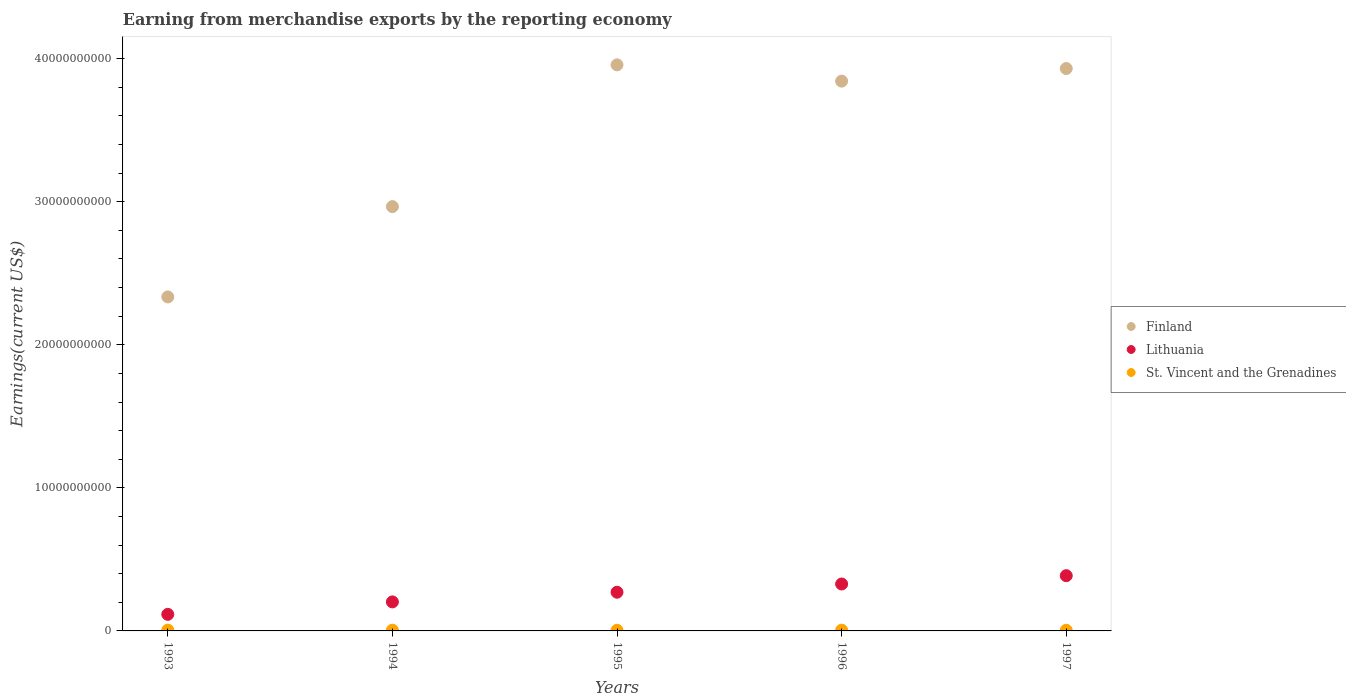How many different coloured dotlines are there?
Keep it short and to the point. 3. What is the amount earned from merchandise exports in Lithuania in 1995?
Ensure brevity in your answer.  2.71e+09. Across all years, what is the maximum amount earned from merchandise exports in St. Vincent and the Grenadines?
Keep it short and to the point. 5.79e+07. Across all years, what is the minimum amount earned from merchandise exports in St. Vincent and the Grenadines?
Your answer should be very brief. 4.45e+07. In which year was the amount earned from merchandise exports in Finland minimum?
Offer a terse response. 1993. What is the total amount earned from merchandise exports in Finland in the graph?
Provide a succinct answer. 1.70e+11. What is the difference between the amount earned from merchandise exports in Finland in 1995 and that in 1996?
Offer a terse response. 1.14e+09. What is the difference between the amount earned from merchandise exports in Lithuania in 1993 and the amount earned from merchandise exports in Finland in 1994?
Make the answer very short. -2.85e+1. What is the average amount earned from merchandise exports in Lithuania per year?
Your response must be concise. 2.61e+09. In the year 1995, what is the difference between the amount earned from merchandise exports in Finland and amount earned from merchandise exports in St. Vincent and the Grenadines?
Keep it short and to the point. 3.95e+1. What is the ratio of the amount earned from merchandise exports in St. Vincent and the Grenadines in 1993 to that in 1995?
Your answer should be compact. 1.3. What is the difference between the highest and the second highest amount earned from merchandise exports in Lithuania?
Provide a succinct answer. 5.81e+08. What is the difference between the highest and the lowest amount earned from merchandise exports in St. Vincent and the Grenadines?
Your answer should be compact. 1.33e+07. In how many years, is the amount earned from merchandise exports in Lithuania greater than the average amount earned from merchandise exports in Lithuania taken over all years?
Ensure brevity in your answer.  3. Is the sum of the amount earned from merchandise exports in Lithuania in 1995 and 1997 greater than the maximum amount earned from merchandise exports in St. Vincent and the Grenadines across all years?
Give a very brief answer. Yes. Is it the case that in every year, the sum of the amount earned from merchandise exports in St. Vincent and the Grenadines and amount earned from merchandise exports in Lithuania  is greater than the amount earned from merchandise exports in Finland?
Your response must be concise. No. Is the amount earned from merchandise exports in Finland strictly greater than the amount earned from merchandise exports in St. Vincent and the Grenadines over the years?
Ensure brevity in your answer.  Yes. Is the amount earned from merchandise exports in Finland strictly less than the amount earned from merchandise exports in St. Vincent and the Grenadines over the years?
Keep it short and to the point. No. How many dotlines are there?
Your answer should be compact. 3. How many years are there in the graph?
Your answer should be compact. 5. What is the difference between two consecutive major ticks on the Y-axis?
Give a very brief answer. 1.00e+1. Does the graph contain any zero values?
Your answer should be compact. No. Does the graph contain grids?
Provide a succinct answer. No. Where does the legend appear in the graph?
Make the answer very short. Center right. How many legend labels are there?
Your answer should be very brief. 3. What is the title of the graph?
Your answer should be compact. Earning from merchandise exports by the reporting economy. Does "Euro area" appear as one of the legend labels in the graph?
Give a very brief answer. No. What is the label or title of the X-axis?
Offer a very short reply. Years. What is the label or title of the Y-axis?
Offer a terse response. Earnings(current US$). What is the Earnings(current US$) of Finland in 1993?
Your response must be concise. 2.33e+1. What is the Earnings(current US$) in Lithuania in 1993?
Your answer should be compact. 1.16e+09. What is the Earnings(current US$) in St. Vincent and the Grenadines in 1993?
Provide a succinct answer. 5.79e+07. What is the Earnings(current US$) of Finland in 1994?
Your response must be concise. 2.97e+1. What is the Earnings(current US$) of Lithuania in 1994?
Give a very brief answer. 2.03e+09. What is the Earnings(current US$) in St. Vincent and the Grenadines in 1994?
Ensure brevity in your answer.  5.04e+07. What is the Earnings(current US$) in Finland in 1995?
Make the answer very short. 3.96e+1. What is the Earnings(current US$) in Lithuania in 1995?
Make the answer very short. 2.71e+09. What is the Earnings(current US$) of St. Vincent and the Grenadines in 1995?
Give a very brief answer. 4.45e+07. What is the Earnings(current US$) in Finland in 1996?
Your answer should be very brief. 3.84e+1. What is the Earnings(current US$) in Lithuania in 1996?
Provide a short and direct response. 3.28e+09. What is the Earnings(current US$) in St. Vincent and the Grenadines in 1996?
Make the answer very short. 5.29e+07. What is the Earnings(current US$) of Finland in 1997?
Keep it short and to the point. 3.93e+1. What is the Earnings(current US$) of Lithuania in 1997?
Provide a succinct answer. 3.86e+09. What is the Earnings(current US$) in St. Vincent and the Grenadines in 1997?
Give a very brief answer. 4.61e+07. Across all years, what is the maximum Earnings(current US$) in Finland?
Keep it short and to the point. 3.96e+1. Across all years, what is the maximum Earnings(current US$) in Lithuania?
Offer a very short reply. 3.86e+09. Across all years, what is the maximum Earnings(current US$) of St. Vincent and the Grenadines?
Make the answer very short. 5.79e+07. Across all years, what is the minimum Earnings(current US$) in Finland?
Give a very brief answer. 2.33e+1. Across all years, what is the minimum Earnings(current US$) of Lithuania?
Give a very brief answer. 1.16e+09. Across all years, what is the minimum Earnings(current US$) of St. Vincent and the Grenadines?
Provide a short and direct response. 4.45e+07. What is the total Earnings(current US$) in Finland in the graph?
Offer a very short reply. 1.70e+11. What is the total Earnings(current US$) of Lithuania in the graph?
Your answer should be very brief. 1.30e+1. What is the total Earnings(current US$) of St. Vincent and the Grenadines in the graph?
Your answer should be compact. 2.52e+08. What is the difference between the Earnings(current US$) of Finland in 1993 and that in 1994?
Provide a short and direct response. -6.32e+09. What is the difference between the Earnings(current US$) of Lithuania in 1993 and that in 1994?
Keep it short and to the point. -8.70e+08. What is the difference between the Earnings(current US$) in St. Vincent and the Grenadines in 1993 and that in 1994?
Your answer should be compact. 7.49e+06. What is the difference between the Earnings(current US$) in Finland in 1993 and that in 1995?
Provide a succinct answer. -1.62e+1. What is the difference between the Earnings(current US$) in Lithuania in 1993 and that in 1995?
Make the answer very short. -1.55e+09. What is the difference between the Earnings(current US$) in St. Vincent and the Grenadines in 1993 and that in 1995?
Your response must be concise. 1.33e+07. What is the difference between the Earnings(current US$) in Finland in 1993 and that in 1996?
Your response must be concise. -1.51e+1. What is the difference between the Earnings(current US$) in Lithuania in 1993 and that in 1996?
Give a very brief answer. -2.12e+09. What is the difference between the Earnings(current US$) of St. Vincent and the Grenadines in 1993 and that in 1996?
Provide a short and direct response. 4.97e+06. What is the difference between the Earnings(current US$) in Finland in 1993 and that in 1997?
Make the answer very short. -1.60e+1. What is the difference between the Earnings(current US$) of Lithuania in 1993 and that in 1997?
Your answer should be very brief. -2.70e+09. What is the difference between the Earnings(current US$) of St. Vincent and the Grenadines in 1993 and that in 1997?
Offer a very short reply. 1.18e+07. What is the difference between the Earnings(current US$) of Finland in 1994 and that in 1995?
Offer a terse response. -9.91e+09. What is the difference between the Earnings(current US$) of Lithuania in 1994 and that in 1995?
Your response must be concise. -6.77e+08. What is the difference between the Earnings(current US$) of St. Vincent and the Grenadines in 1994 and that in 1995?
Provide a succinct answer. 5.84e+06. What is the difference between the Earnings(current US$) in Finland in 1994 and that in 1996?
Keep it short and to the point. -8.77e+09. What is the difference between the Earnings(current US$) in Lithuania in 1994 and that in 1996?
Provide a short and direct response. -1.25e+09. What is the difference between the Earnings(current US$) of St. Vincent and the Grenadines in 1994 and that in 1996?
Offer a terse response. -2.52e+06. What is the difference between the Earnings(current US$) of Finland in 1994 and that in 1997?
Provide a succinct answer. -9.65e+09. What is the difference between the Earnings(current US$) of Lithuania in 1994 and that in 1997?
Ensure brevity in your answer.  -1.83e+09. What is the difference between the Earnings(current US$) of St. Vincent and the Grenadines in 1994 and that in 1997?
Provide a short and direct response. 4.30e+06. What is the difference between the Earnings(current US$) of Finland in 1995 and that in 1996?
Provide a short and direct response. 1.14e+09. What is the difference between the Earnings(current US$) of Lithuania in 1995 and that in 1996?
Offer a terse response. -5.75e+08. What is the difference between the Earnings(current US$) in St. Vincent and the Grenadines in 1995 and that in 1996?
Offer a very short reply. -8.36e+06. What is the difference between the Earnings(current US$) in Finland in 1995 and that in 1997?
Offer a terse response. 2.57e+08. What is the difference between the Earnings(current US$) in Lithuania in 1995 and that in 1997?
Offer a terse response. -1.16e+09. What is the difference between the Earnings(current US$) of St. Vincent and the Grenadines in 1995 and that in 1997?
Your answer should be compact. -1.53e+06. What is the difference between the Earnings(current US$) of Finland in 1996 and that in 1997?
Provide a succinct answer. -8.82e+08. What is the difference between the Earnings(current US$) of Lithuania in 1996 and that in 1997?
Your answer should be compact. -5.81e+08. What is the difference between the Earnings(current US$) in St. Vincent and the Grenadines in 1996 and that in 1997?
Keep it short and to the point. 6.83e+06. What is the difference between the Earnings(current US$) of Finland in 1993 and the Earnings(current US$) of Lithuania in 1994?
Your answer should be compact. 2.13e+1. What is the difference between the Earnings(current US$) of Finland in 1993 and the Earnings(current US$) of St. Vincent and the Grenadines in 1994?
Make the answer very short. 2.33e+1. What is the difference between the Earnings(current US$) in Lithuania in 1993 and the Earnings(current US$) in St. Vincent and the Grenadines in 1994?
Your response must be concise. 1.11e+09. What is the difference between the Earnings(current US$) of Finland in 1993 and the Earnings(current US$) of Lithuania in 1995?
Your response must be concise. 2.06e+1. What is the difference between the Earnings(current US$) of Finland in 1993 and the Earnings(current US$) of St. Vincent and the Grenadines in 1995?
Give a very brief answer. 2.33e+1. What is the difference between the Earnings(current US$) of Lithuania in 1993 and the Earnings(current US$) of St. Vincent and the Grenadines in 1995?
Your answer should be very brief. 1.11e+09. What is the difference between the Earnings(current US$) of Finland in 1993 and the Earnings(current US$) of Lithuania in 1996?
Keep it short and to the point. 2.01e+1. What is the difference between the Earnings(current US$) in Finland in 1993 and the Earnings(current US$) in St. Vincent and the Grenadines in 1996?
Your response must be concise. 2.33e+1. What is the difference between the Earnings(current US$) of Lithuania in 1993 and the Earnings(current US$) of St. Vincent and the Grenadines in 1996?
Your response must be concise. 1.11e+09. What is the difference between the Earnings(current US$) in Finland in 1993 and the Earnings(current US$) in Lithuania in 1997?
Give a very brief answer. 1.95e+1. What is the difference between the Earnings(current US$) of Finland in 1993 and the Earnings(current US$) of St. Vincent and the Grenadines in 1997?
Your answer should be compact. 2.33e+1. What is the difference between the Earnings(current US$) of Lithuania in 1993 and the Earnings(current US$) of St. Vincent and the Grenadines in 1997?
Make the answer very short. 1.11e+09. What is the difference between the Earnings(current US$) of Finland in 1994 and the Earnings(current US$) of Lithuania in 1995?
Offer a very short reply. 2.70e+1. What is the difference between the Earnings(current US$) in Finland in 1994 and the Earnings(current US$) in St. Vincent and the Grenadines in 1995?
Your answer should be very brief. 2.96e+1. What is the difference between the Earnings(current US$) of Lithuania in 1994 and the Earnings(current US$) of St. Vincent and the Grenadines in 1995?
Offer a terse response. 1.98e+09. What is the difference between the Earnings(current US$) of Finland in 1994 and the Earnings(current US$) of Lithuania in 1996?
Provide a succinct answer. 2.64e+1. What is the difference between the Earnings(current US$) in Finland in 1994 and the Earnings(current US$) in St. Vincent and the Grenadines in 1996?
Make the answer very short. 2.96e+1. What is the difference between the Earnings(current US$) of Lithuania in 1994 and the Earnings(current US$) of St. Vincent and the Grenadines in 1996?
Keep it short and to the point. 1.98e+09. What is the difference between the Earnings(current US$) of Finland in 1994 and the Earnings(current US$) of Lithuania in 1997?
Your response must be concise. 2.58e+1. What is the difference between the Earnings(current US$) of Finland in 1994 and the Earnings(current US$) of St. Vincent and the Grenadines in 1997?
Your answer should be very brief. 2.96e+1. What is the difference between the Earnings(current US$) of Lithuania in 1994 and the Earnings(current US$) of St. Vincent and the Grenadines in 1997?
Make the answer very short. 1.98e+09. What is the difference between the Earnings(current US$) in Finland in 1995 and the Earnings(current US$) in Lithuania in 1996?
Provide a succinct answer. 3.63e+1. What is the difference between the Earnings(current US$) of Finland in 1995 and the Earnings(current US$) of St. Vincent and the Grenadines in 1996?
Offer a terse response. 3.95e+1. What is the difference between the Earnings(current US$) of Lithuania in 1995 and the Earnings(current US$) of St. Vincent and the Grenadines in 1996?
Ensure brevity in your answer.  2.65e+09. What is the difference between the Earnings(current US$) in Finland in 1995 and the Earnings(current US$) in Lithuania in 1997?
Keep it short and to the point. 3.57e+1. What is the difference between the Earnings(current US$) of Finland in 1995 and the Earnings(current US$) of St. Vincent and the Grenadines in 1997?
Offer a very short reply. 3.95e+1. What is the difference between the Earnings(current US$) of Lithuania in 1995 and the Earnings(current US$) of St. Vincent and the Grenadines in 1997?
Offer a terse response. 2.66e+09. What is the difference between the Earnings(current US$) of Finland in 1996 and the Earnings(current US$) of Lithuania in 1997?
Keep it short and to the point. 3.46e+1. What is the difference between the Earnings(current US$) in Finland in 1996 and the Earnings(current US$) in St. Vincent and the Grenadines in 1997?
Your answer should be compact. 3.84e+1. What is the difference between the Earnings(current US$) of Lithuania in 1996 and the Earnings(current US$) of St. Vincent and the Grenadines in 1997?
Keep it short and to the point. 3.24e+09. What is the average Earnings(current US$) in Finland per year?
Provide a succinct answer. 3.41e+1. What is the average Earnings(current US$) of Lithuania per year?
Give a very brief answer. 2.61e+09. What is the average Earnings(current US$) in St. Vincent and the Grenadines per year?
Provide a succinct answer. 5.03e+07. In the year 1993, what is the difference between the Earnings(current US$) of Finland and Earnings(current US$) of Lithuania?
Provide a succinct answer. 2.22e+1. In the year 1993, what is the difference between the Earnings(current US$) in Finland and Earnings(current US$) in St. Vincent and the Grenadines?
Make the answer very short. 2.33e+1. In the year 1993, what is the difference between the Earnings(current US$) in Lithuania and Earnings(current US$) in St. Vincent and the Grenadines?
Your answer should be very brief. 1.10e+09. In the year 1994, what is the difference between the Earnings(current US$) in Finland and Earnings(current US$) in Lithuania?
Make the answer very short. 2.76e+1. In the year 1994, what is the difference between the Earnings(current US$) in Finland and Earnings(current US$) in St. Vincent and the Grenadines?
Give a very brief answer. 2.96e+1. In the year 1994, what is the difference between the Earnings(current US$) of Lithuania and Earnings(current US$) of St. Vincent and the Grenadines?
Give a very brief answer. 1.98e+09. In the year 1995, what is the difference between the Earnings(current US$) in Finland and Earnings(current US$) in Lithuania?
Ensure brevity in your answer.  3.69e+1. In the year 1995, what is the difference between the Earnings(current US$) of Finland and Earnings(current US$) of St. Vincent and the Grenadines?
Provide a succinct answer. 3.95e+1. In the year 1995, what is the difference between the Earnings(current US$) of Lithuania and Earnings(current US$) of St. Vincent and the Grenadines?
Provide a succinct answer. 2.66e+09. In the year 1996, what is the difference between the Earnings(current US$) of Finland and Earnings(current US$) of Lithuania?
Your response must be concise. 3.52e+1. In the year 1996, what is the difference between the Earnings(current US$) of Finland and Earnings(current US$) of St. Vincent and the Grenadines?
Give a very brief answer. 3.84e+1. In the year 1996, what is the difference between the Earnings(current US$) in Lithuania and Earnings(current US$) in St. Vincent and the Grenadines?
Provide a succinct answer. 3.23e+09. In the year 1997, what is the difference between the Earnings(current US$) of Finland and Earnings(current US$) of Lithuania?
Your answer should be very brief. 3.55e+1. In the year 1997, what is the difference between the Earnings(current US$) of Finland and Earnings(current US$) of St. Vincent and the Grenadines?
Your answer should be very brief. 3.93e+1. In the year 1997, what is the difference between the Earnings(current US$) of Lithuania and Earnings(current US$) of St. Vincent and the Grenadines?
Your answer should be compact. 3.82e+09. What is the ratio of the Earnings(current US$) in Finland in 1993 to that in 1994?
Your response must be concise. 0.79. What is the ratio of the Earnings(current US$) of Lithuania in 1993 to that in 1994?
Your answer should be compact. 0.57. What is the ratio of the Earnings(current US$) of St. Vincent and the Grenadines in 1993 to that in 1994?
Ensure brevity in your answer.  1.15. What is the ratio of the Earnings(current US$) in Finland in 1993 to that in 1995?
Make the answer very short. 0.59. What is the ratio of the Earnings(current US$) of Lithuania in 1993 to that in 1995?
Provide a short and direct response. 0.43. What is the ratio of the Earnings(current US$) in St. Vincent and the Grenadines in 1993 to that in 1995?
Keep it short and to the point. 1.3. What is the ratio of the Earnings(current US$) in Finland in 1993 to that in 1996?
Your response must be concise. 0.61. What is the ratio of the Earnings(current US$) of Lithuania in 1993 to that in 1996?
Keep it short and to the point. 0.35. What is the ratio of the Earnings(current US$) in St. Vincent and the Grenadines in 1993 to that in 1996?
Offer a very short reply. 1.09. What is the ratio of the Earnings(current US$) in Finland in 1993 to that in 1997?
Provide a short and direct response. 0.59. What is the ratio of the Earnings(current US$) in St. Vincent and the Grenadines in 1993 to that in 1997?
Your answer should be very brief. 1.26. What is the ratio of the Earnings(current US$) in Finland in 1994 to that in 1995?
Keep it short and to the point. 0.75. What is the ratio of the Earnings(current US$) in Lithuania in 1994 to that in 1995?
Ensure brevity in your answer.  0.75. What is the ratio of the Earnings(current US$) of St. Vincent and the Grenadines in 1994 to that in 1995?
Your answer should be compact. 1.13. What is the ratio of the Earnings(current US$) in Finland in 1994 to that in 1996?
Offer a very short reply. 0.77. What is the ratio of the Earnings(current US$) of Lithuania in 1994 to that in 1996?
Your answer should be very brief. 0.62. What is the ratio of the Earnings(current US$) in St. Vincent and the Grenadines in 1994 to that in 1996?
Provide a succinct answer. 0.95. What is the ratio of the Earnings(current US$) of Finland in 1994 to that in 1997?
Ensure brevity in your answer.  0.75. What is the ratio of the Earnings(current US$) of Lithuania in 1994 to that in 1997?
Your answer should be compact. 0.53. What is the ratio of the Earnings(current US$) of St. Vincent and the Grenadines in 1994 to that in 1997?
Give a very brief answer. 1.09. What is the ratio of the Earnings(current US$) in Finland in 1995 to that in 1996?
Keep it short and to the point. 1.03. What is the ratio of the Earnings(current US$) in Lithuania in 1995 to that in 1996?
Provide a succinct answer. 0.82. What is the ratio of the Earnings(current US$) in St. Vincent and the Grenadines in 1995 to that in 1996?
Offer a very short reply. 0.84. What is the ratio of the Earnings(current US$) of Finland in 1995 to that in 1997?
Your answer should be very brief. 1.01. What is the ratio of the Earnings(current US$) in Lithuania in 1995 to that in 1997?
Keep it short and to the point. 0.7. What is the ratio of the Earnings(current US$) in St. Vincent and the Grenadines in 1995 to that in 1997?
Your response must be concise. 0.97. What is the ratio of the Earnings(current US$) in Finland in 1996 to that in 1997?
Provide a short and direct response. 0.98. What is the ratio of the Earnings(current US$) of Lithuania in 1996 to that in 1997?
Make the answer very short. 0.85. What is the ratio of the Earnings(current US$) of St. Vincent and the Grenadines in 1996 to that in 1997?
Your answer should be compact. 1.15. What is the difference between the highest and the second highest Earnings(current US$) in Finland?
Keep it short and to the point. 2.57e+08. What is the difference between the highest and the second highest Earnings(current US$) of Lithuania?
Offer a very short reply. 5.81e+08. What is the difference between the highest and the second highest Earnings(current US$) of St. Vincent and the Grenadines?
Provide a short and direct response. 4.97e+06. What is the difference between the highest and the lowest Earnings(current US$) in Finland?
Offer a very short reply. 1.62e+1. What is the difference between the highest and the lowest Earnings(current US$) of Lithuania?
Ensure brevity in your answer.  2.70e+09. What is the difference between the highest and the lowest Earnings(current US$) in St. Vincent and the Grenadines?
Your response must be concise. 1.33e+07. 